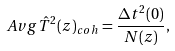Convert formula to latex. <formula><loc_0><loc_0><loc_500><loc_500>\ A v g { \hat { T } ^ { 2 } ( z ) } _ { c o h } = \frac { \Delta t ^ { 2 } ( 0 ) } { N ( z ) } ,</formula> 